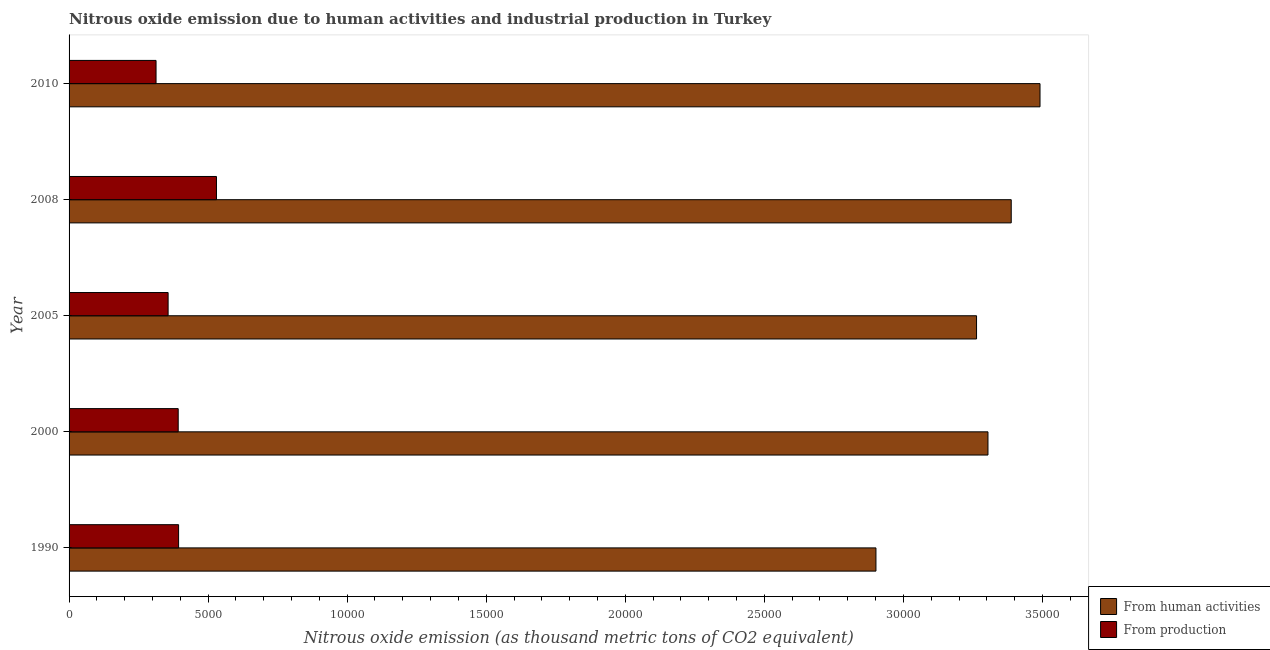How many bars are there on the 5th tick from the top?
Ensure brevity in your answer.  2. What is the label of the 5th group of bars from the top?
Provide a short and direct response. 1990. What is the amount of emissions from human activities in 2008?
Keep it short and to the point. 3.39e+04. Across all years, what is the maximum amount of emissions generated from industries?
Your response must be concise. 5300.3. Across all years, what is the minimum amount of emissions from human activities?
Your response must be concise. 2.90e+04. In which year was the amount of emissions generated from industries maximum?
Provide a short and direct response. 2008. In which year was the amount of emissions from human activities minimum?
Make the answer very short. 1990. What is the total amount of emissions generated from industries in the graph?
Your answer should be compact. 1.99e+04. What is the difference between the amount of emissions from human activities in 2000 and that in 2005?
Provide a succinct answer. 410.2. What is the difference between the amount of emissions generated from industries in 2000 and the amount of emissions from human activities in 2005?
Your answer should be compact. -2.87e+04. What is the average amount of emissions from human activities per year?
Your answer should be compact. 3.27e+04. In the year 2008, what is the difference between the amount of emissions from human activities and amount of emissions generated from industries?
Provide a succinct answer. 2.86e+04. In how many years, is the amount of emissions generated from industries greater than 33000 thousand metric tons?
Your answer should be very brief. 0. Is the amount of emissions generated from industries in 2008 less than that in 2010?
Offer a terse response. No. What is the difference between the highest and the second highest amount of emissions generated from industries?
Provide a succinct answer. 1362.2. What is the difference between the highest and the lowest amount of emissions from human activities?
Keep it short and to the point. 5899.6. In how many years, is the amount of emissions from human activities greater than the average amount of emissions from human activities taken over all years?
Offer a terse response. 3. What does the 2nd bar from the top in 1990 represents?
Offer a terse response. From human activities. What does the 2nd bar from the bottom in 1990 represents?
Ensure brevity in your answer.  From production. What is the difference between two consecutive major ticks on the X-axis?
Offer a very short reply. 5000. Are the values on the major ticks of X-axis written in scientific E-notation?
Offer a very short reply. No. Does the graph contain any zero values?
Provide a succinct answer. No. Does the graph contain grids?
Your response must be concise. No. Where does the legend appear in the graph?
Your answer should be very brief. Bottom right. How many legend labels are there?
Give a very brief answer. 2. How are the legend labels stacked?
Provide a succinct answer. Vertical. What is the title of the graph?
Offer a very short reply. Nitrous oxide emission due to human activities and industrial production in Turkey. Does "Male population" appear as one of the legend labels in the graph?
Keep it short and to the point. No. What is the label or title of the X-axis?
Keep it short and to the point. Nitrous oxide emission (as thousand metric tons of CO2 equivalent). What is the label or title of the Y-axis?
Your response must be concise. Year. What is the Nitrous oxide emission (as thousand metric tons of CO2 equivalent) of From human activities in 1990?
Make the answer very short. 2.90e+04. What is the Nitrous oxide emission (as thousand metric tons of CO2 equivalent) of From production in 1990?
Provide a succinct answer. 3938.1. What is the Nitrous oxide emission (as thousand metric tons of CO2 equivalent) of From human activities in 2000?
Ensure brevity in your answer.  3.30e+04. What is the Nitrous oxide emission (as thousand metric tons of CO2 equivalent) of From production in 2000?
Ensure brevity in your answer.  3923.9. What is the Nitrous oxide emission (as thousand metric tons of CO2 equivalent) in From human activities in 2005?
Your response must be concise. 3.26e+04. What is the Nitrous oxide emission (as thousand metric tons of CO2 equivalent) in From production in 2005?
Provide a short and direct response. 3561.4. What is the Nitrous oxide emission (as thousand metric tons of CO2 equivalent) in From human activities in 2008?
Provide a succinct answer. 3.39e+04. What is the Nitrous oxide emission (as thousand metric tons of CO2 equivalent) of From production in 2008?
Keep it short and to the point. 5300.3. What is the Nitrous oxide emission (as thousand metric tons of CO2 equivalent) in From human activities in 2010?
Ensure brevity in your answer.  3.49e+04. What is the Nitrous oxide emission (as thousand metric tons of CO2 equivalent) in From production in 2010?
Your answer should be very brief. 3127.4. Across all years, what is the maximum Nitrous oxide emission (as thousand metric tons of CO2 equivalent) in From human activities?
Your answer should be compact. 3.49e+04. Across all years, what is the maximum Nitrous oxide emission (as thousand metric tons of CO2 equivalent) in From production?
Keep it short and to the point. 5300.3. Across all years, what is the minimum Nitrous oxide emission (as thousand metric tons of CO2 equivalent) in From human activities?
Your answer should be very brief. 2.90e+04. Across all years, what is the minimum Nitrous oxide emission (as thousand metric tons of CO2 equivalent) of From production?
Ensure brevity in your answer.  3127.4. What is the total Nitrous oxide emission (as thousand metric tons of CO2 equivalent) in From human activities in the graph?
Ensure brevity in your answer.  1.63e+05. What is the total Nitrous oxide emission (as thousand metric tons of CO2 equivalent) of From production in the graph?
Your answer should be very brief. 1.99e+04. What is the difference between the Nitrous oxide emission (as thousand metric tons of CO2 equivalent) in From human activities in 1990 and that in 2000?
Offer a very short reply. -4027.6. What is the difference between the Nitrous oxide emission (as thousand metric tons of CO2 equivalent) of From production in 1990 and that in 2000?
Your response must be concise. 14.2. What is the difference between the Nitrous oxide emission (as thousand metric tons of CO2 equivalent) of From human activities in 1990 and that in 2005?
Offer a terse response. -3617.4. What is the difference between the Nitrous oxide emission (as thousand metric tons of CO2 equivalent) of From production in 1990 and that in 2005?
Offer a very short reply. 376.7. What is the difference between the Nitrous oxide emission (as thousand metric tons of CO2 equivalent) of From human activities in 1990 and that in 2008?
Your answer should be very brief. -4864.2. What is the difference between the Nitrous oxide emission (as thousand metric tons of CO2 equivalent) of From production in 1990 and that in 2008?
Provide a short and direct response. -1362.2. What is the difference between the Nitrous oxide emission (as thousand metric tons of CO2 equivalent) of From human activities in 1990 and that in 2010?
Give a very brief answer. -5899.6. What is the difference between the Nitrous oxide emission (as thousand metric tons of CO2 equivalent) of From production in 1990 and that in 2010?
Your answer should be very brief. 810.7. What is the difference between the Nitrous oxide emission (as thousand metric tons of CO2 equivalent) of From human activities in 2000 and that in 2005?
Keep it short and to the point. 410.2. What is the difference between the Nitrous oxide emission (as thousand metric tons of CO2 equivalent) of From production in 2000 and that in 2005?
Provide a short and direct response. 362.5. What is the difference between the Nitrous oxide emission (as thousand metric tons of CO2 equivalent) of From human activities in 2000 and that in 2008?
Offer a very short reply. -836.6. What is the difference between the Nitrous oxide emission (as thousand metric tons of CO2 equivalent) in From production in 2000 and that in 2008?
Your answer should be compact. -1376.4. What is the difference between the Nitrous oxide emission (as thousand metric tons of CO2 equivalent) of From human activities in 2000 and that in 2010?
Give a very brief answer. -1872. What is the difference between the Nitrous oxide emission (as thousand metric tons of CO2 equivalent) of From production in 2000 and that in 2010?
Your answer should be very brief. 796.5. What is the difference between the Nitrous oxide emission (as thousand metric tons of CO2 equivalent) of From human activities in 2005 and that in 2008?
Provide a short and direct response. -1246.8. What is the difference between the Nitrous oxide emission (as thousand metric tons of CO2 equivalent) of From production in 2005 and that in 2008?
Your answer should be compact. -1738.9. What is the difference between the Nitrous oxide emission (as thousand metric tons of CO2 equivalent) in From human activities in 2005 and that in 2010?
Ensure brevity in your answer.  -2282.2. What is the difference between the Nitrous oxide emission (as thousand metric tons of CO2 equivalent) of From production in 2005 and that in 2010?
Offer a terse response. 434. What is the difference between the Nitrous oxide emission (as thousand metric tons of CO2 equivalent) in From human activities in 2008 and that in 2010?
Ensure brevity in your answer.  -1035.4. What is the difference between the Nitrous oxide emission (as thousand metric tons of CO2 equivalent) in From production in 2008 and that in 2010?
Offer a very short reply. 2172.9. What is the difference between the Nitrous oxide emission (as thousand metric tons of CO2 equivalent) of From human activities in 1990 and the Nitrous oxide emission (as thousand metric tons of CO2 equivalent) of From production in 2000?
Make the answer very short. 2.51e+04. What is the difference between the Nitrous oxide emission (as thousand metric tons of CO2 equivalent) in From human activities in 1990 and the Nitrous oxide emission (as thousand metric tons of CO2 equivalent) in From production in 2005?
Provide a short and direct response. 2.55e+04. What is the difference between the Nitrous oxide emission (as thousand metric tons of CO2 equivalent) in From human activities in 1990 and the Nitrous oxide emission (as thousand metric tons of CO2 equivalent) in From production in 2008?
Ensure brevity in your answer.  2.37e+04. What is the difference between the Nitrous oxide emission (as thousand metric tons of CO2 equivalent) of From human activities in 1990 and the Nitrous oxide emission (as thousand metric tons of CO2 equivalent) of From production in 2010?
Offer a very short reply. 2.59e+04. What is the difference between the Nitrous oxide emission (as thousand metric tons of CO2 equivalent) in From human activities in 2000 and the Nitrous oxide emission (as thousand metric tons of CO2 equivalent) in From production in 2005?
Give a very brief answer. 2.95e+04. What is the difference between the Nitrous oxide emission (as thousand metric tons of CO2 equivalent) in From human activities in 2000 and the Nitrous oxide emission (as thousand metric tons of CO2 equivalent) in From production in 2008?
Make the answer very short. 2.77e+04. What is the difference between the Nitrous oxide emission (as thousand metric tons of CO2 equivalent) in From human activities in 2000 and the Nitrous oxide emission (as thousand metric tons of CO2 equivalent) in From production in 2010?
Provide a short and direct response. 2.99e+04. What is the difference between the Nitrous oxide emission (as thousand metric tons of CO2 equivalent) of From human activities in 2005 and the Nitrous oxide emission (as thousand metric tons of CO2 equivalent) of From production in 2008?
Your answer should be very brief. 2.73e+04. What is the difference between the Nitrous oxide emission (as thousand metric tons of CO2 equivalent) in From human activities in 2005 and the Nitrous oxide emission (as thousand metric tons of CO2 equivalent) in From production in 2010?
Make the answer very short. 2.95e+04. What is the difference between the Nitrous oxide emission (as thousand metric tons of CO2 equivalent) in From human activities in 2008 and the Nitrous oxide emission (as thousand metric tons of CO2 equivalent) in From production in 2010?
Your answer should be compact. 3.08e+04. What is the average Nitrous oxide emission (as thousand metric tons of CO2 equivalent) of From human activities per year?
Offer a terse response. 3.27e+04. What is the average Nitrous oxide emission (as thousand metric tons of CO2 equivalent) in From production per year?
Your response must be concise. 3970.22. In the year 1990, what is the difference between the Nitrous oxide emission (as thousand metric tons of CO2 equivalent) in From human activities and Nitrous oxide emission (as thousand metric tons of CO2 equivalent) in From production?
Give a very brief answer. 2.51e+04. In the year 2000, what is the difference between the Nitrous oxide emission (as thousand metric tons of CO2 equivalent) of From human activities and Nitrous oxide emission (as thousand metric tons of CO2 equivalent) of From production?
Make the answer very short. 2.91e+04. In the year 2005, what is the difference between the Nitrous oxide emission (as thousand metric tons of CO2 equivalent) of From human activities and Nitrous oxide emission (as thousand metric tons of CO2 equivalent) of From production?
Ensure brevity in your answer.  2.91e+04. In the year 2008, what is the difference between the Nitrous oxide emission (as thousand metric tons of CO2 equivalent) of From human activities and Nitrous oxide emission (as thousand metric tons of CO2 equivalent) of From production?
Give a very brief answer. 2.86e+04. In the year 2010, what is the difference between the Nitrous oxide emission (as thousand metric tons of CO2 equivalent) in From human activities and Nitrous oxide emission (as thousand metric tons of CO2 equivalent) in From production?
Provide a succinct answer. 3.18e+04. What is the ratio of the Nitrous oxide emission (as thousand metric tons of CO2 equivalent) of From human activities in 1990 to that in 2000?
Your answer should be compact. 0.88. What is the ratio of the Nitrous oxide emission (as thousand metric tons of CO2 equivalent) of From human activities in 1990 to that in 2005?
Offer a very short reply. 0.89. What is the ratio of the Nitrous oxide emission (as thousand metric tons of CO2 equivalent) of From production in 1990 to that in 2005?
Keep it short and to the point. 1.11. What is the ratio of the Nitrous oxide emission (as thousand metric tons of CO2 equivalent) of From human activities in 1990 to that in 2008?
Give a very brief answer. 0.86. What is the ratio of the Nitrous oxide emission (as thousand metric tons of CO2 equivalent) of From production in 1990 to that in 2008?
Your response must be concise. 0.74. What is the ratio of the Nitrous oxide emission (as thousand metric tons of CO2 equivalent) of From human activities in 1990 to that in 2010?
Ensure brevity in your answer.  0.83. What is the ratio of the Nitrous oxide emission (as thousand metric tons of CO2 equivalent) of From production in 1990 to that in 2010?
Ensure brevity in your answer.  1.26. What is the ratio of the Nitrous oxide emission (as thousand metric tons of CO2 equivalent) of From human activities in 2000 to that in 2005?
Make the answer very short. 1.01. What is the ratio of the Nitrous oxide emission (as thousand metric tons of CO2 equivalent) of From production in 2000 to that in 2005?
Your response must be concise. 1.1. What is the ratio of the Nitrous oxide emission (as thousand metric tons of CO2 equivalent) of From human activities in 2000 to that in 2008?
Make the answer very short. 0.98. What is the ratio of the Nitrous oxide emission (as thousand metric tons of CO2 equivalent) in From production in 2000 to that in 2008?
Your answer should be compact. 0.74. What is the ratio of the Nitrous oxide emission (as thousand metric tons of CO2 equivalent) of From human activities in 2000 to that in 2010?
Ensure brevity in your answer.  0.95. What is the ratio of the Nitrous oxide emission (as thousand metric tons of CO2 equivalent) of From production in 2000 to that in 2010?
Provide a succinct answer. 1.25. What is the ratio of the Nitrous oxide emission (as thousand metric tons of CO2 equivalent) of From human activities in 2005 to that in 2008?
Ensure brevity in your answer.  0.96. What is the ratio of the Nitrous oxide emission (as thousand metric tons of CO2 equivalent) in From production in 2005 to that in 2008?
Keep it short and to the point. 0.67. What is the ratio of the Nitrous oxide emission (as thousand metric tons of CO2 equivalent) in From human activities in 2005 to that in 2010?
Provide a succinct answer. 0.93. What is the ratio of the Nitrous oxide emission (as thousand metric tons of CO2 equivalent) in From production in 2005 to that in 2010?
Offer a terse response. 1.14. What is the ratio of the Nitrous oxide emission (as thousand metric tons of CO2 equivalent) in From human activities in 2008 to that in 2010?
Your answer should be very brief. 0.97. What is the ratio of the Nitrous oxide emission (as thousand metric tons of CO2 equivalent) in From production in 2008 to that in 2010?
Ensure brevity in your answer.  1.69. What is the difference between the highest and the second highest Nitrous oxide emission (as thousand metric tons of CO2 equivalent) in From human activities?
Your answer should be very brief. 1035.4. What is the difference between the highest and the second highest Nitrous oxide emission (as thousand metric tons of CO2 equivalent) of From production?
Provide a short and direct response. 1362.2. What is the difference between the highest and the lowest Nitrous oxide emission (as thousand metric tons of CO2 equivalent) of From human activities?
Keep it short and to the point. 5899.6. What is the difference between the highest and the lowest Nitrous oxide emission (as thousand metric tons of CO2 equivalent) of From production?
Keep it short and to the point. 2172.9. 